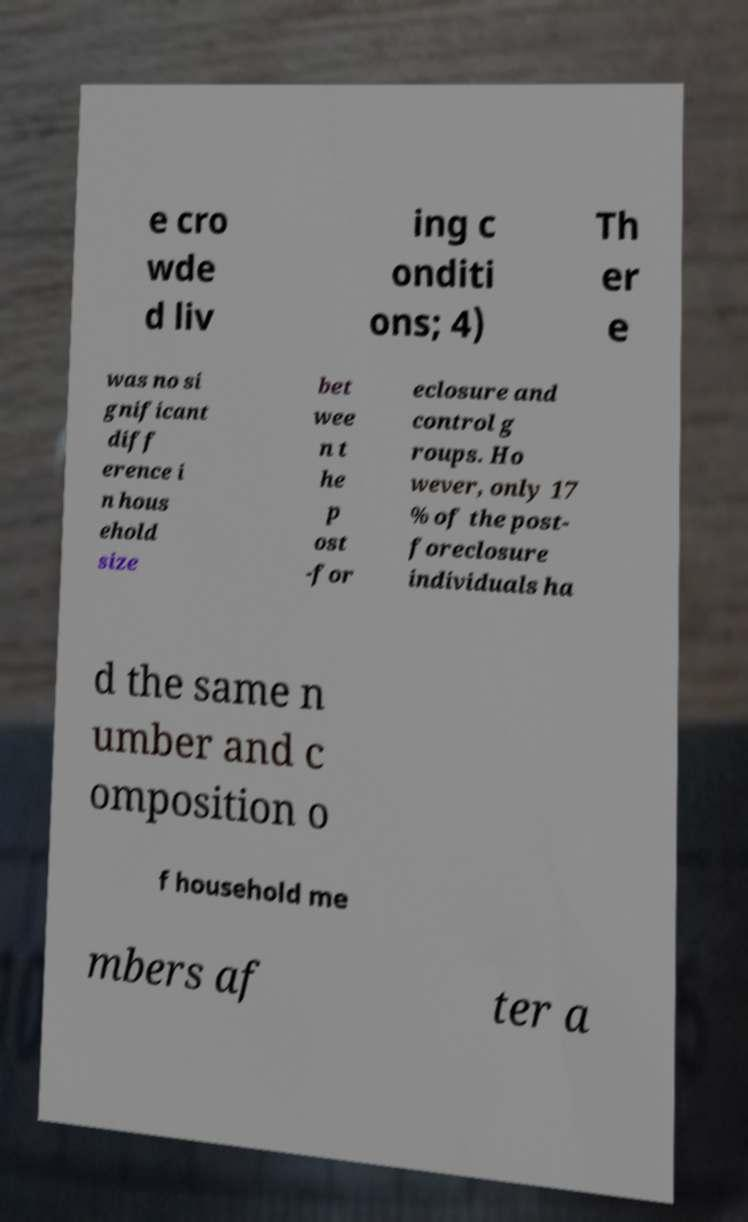Please read and relay the text visible in this image. What does it say? e cro wde d liv ing c onditi ons; 4) Th er e was no si gnificant diff erence i n hous ehold size bet wee n t he p ost -for eclosure and control g roups. Ho wever, only 17 % of the post- foreclosure individuals ha d the same n umber and c omposition o f household me mbers af ter a 